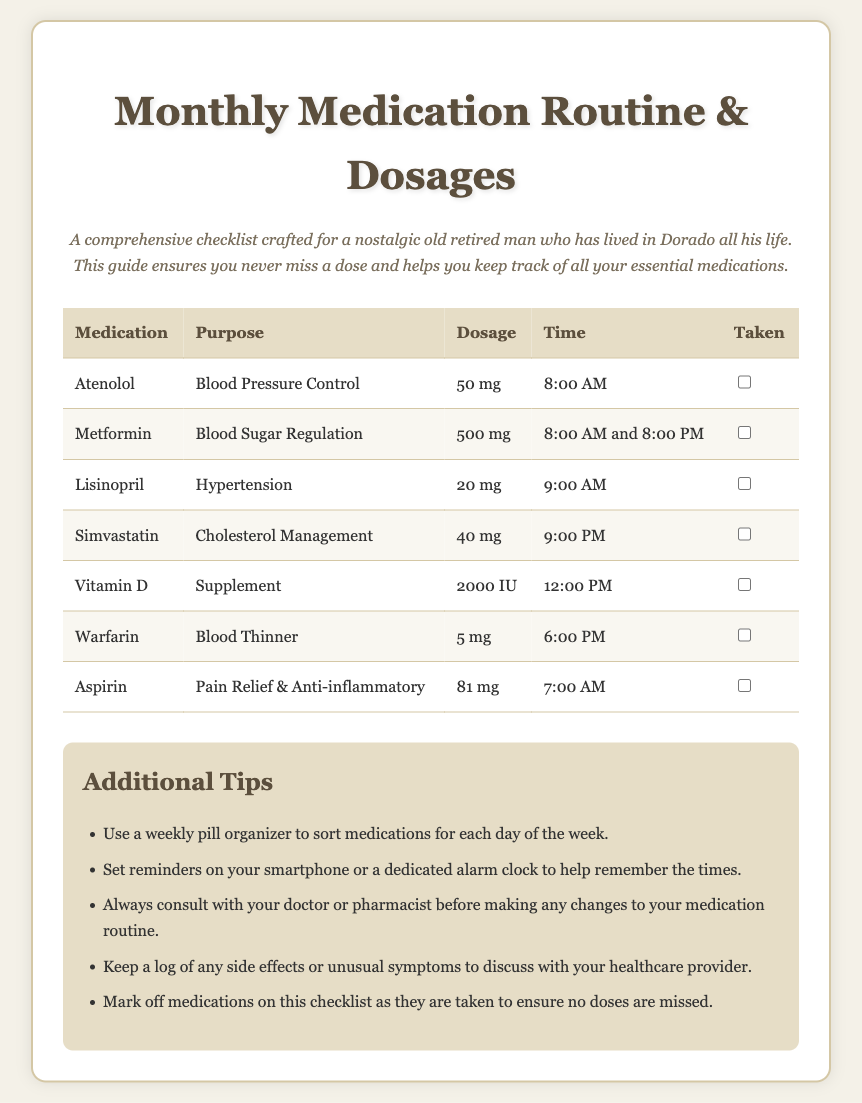What is the purpose of Atenolol? Atenolol is used for Blood Pressure Control as indicated in the document.
Answer: Blood Pressure Control What is the dosage for Metformin? Metformin has a specified dosage of 500 mg listed in the medication checklist.
Answer: 500 mg At what time should Aspirin be taken? Aspirin should be taken at 7:00 AM according to the schedule in the document.
Answer: 7:00 AM How many medications are listed in the document? By counting the medications in the checklist, there are a total of 7 medications listed.
Answer: 7 What additional tip suggests a way to help remember medication times? The document suggests setting reminders on your smartphone or a dedicated alarm clock as a way to help remember.
Answer: Set reminders What is the dosage of Warfarin? The dosage of Warfarin mentioned in the document is 5 mg.
Answer: 5 mg Which medication is taken twice a day? Metformin is the medication that is scheduled to be taken at both 8:00 AM and 8:00 PM.
Answer: Metformin What common theme is indicated for all medications listed? All medications are related to chronic health management, focusing on conditions like blood pressure and sugar levels.
Answer: Chronic health management 